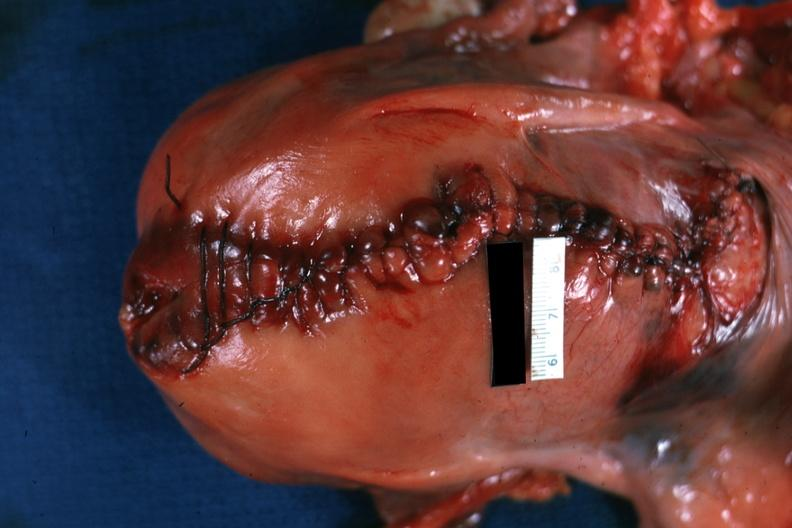where does this part belong to?
Answer the question using a single word or phrase. Female reproductive system 